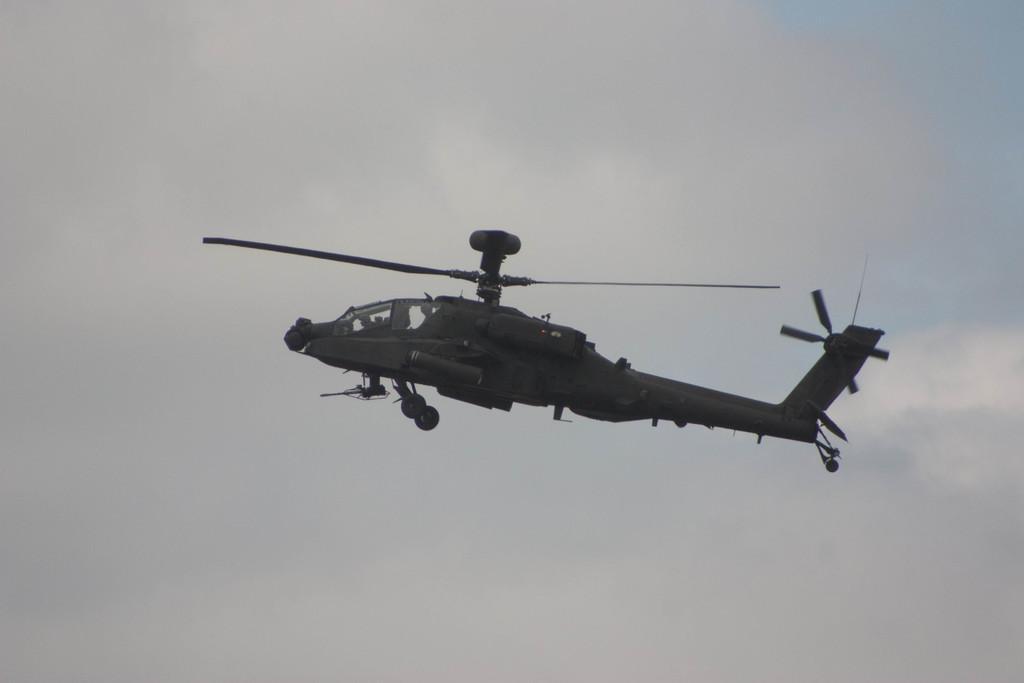Could you give a brief overview of what you see in this image? In this picture we can see a helicopter in the air, and also we can see clouds. 